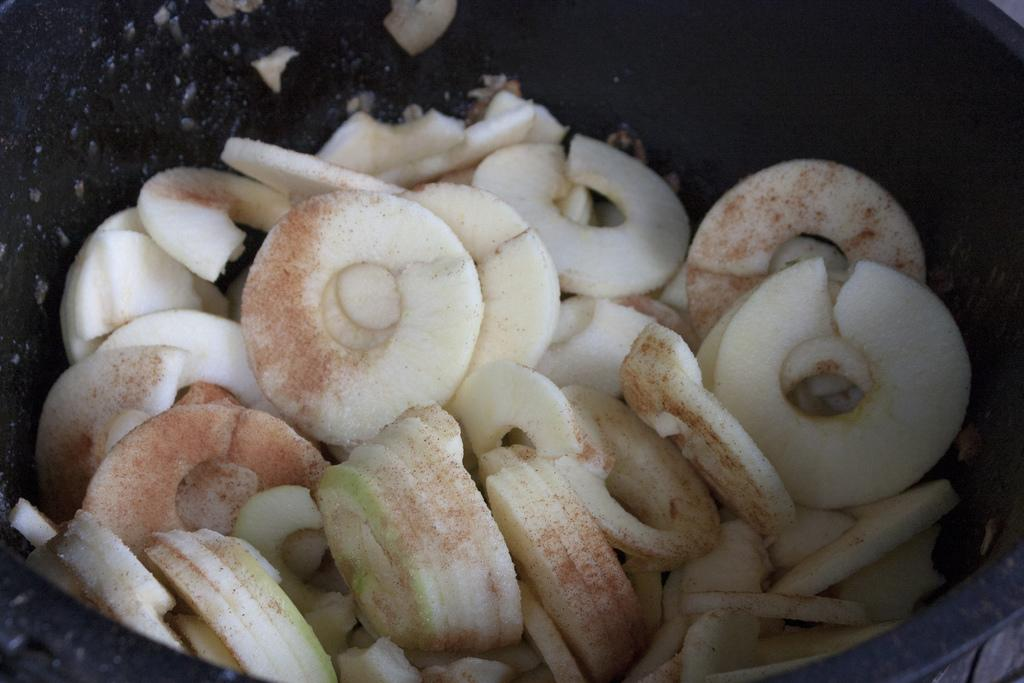What is in the bowl that is visible in the image? There is food in a bowl in the image. How does the food in the bowl help control the stem in the image? There is no stem present in the image, and the food in the bowl does not have any control over it. 